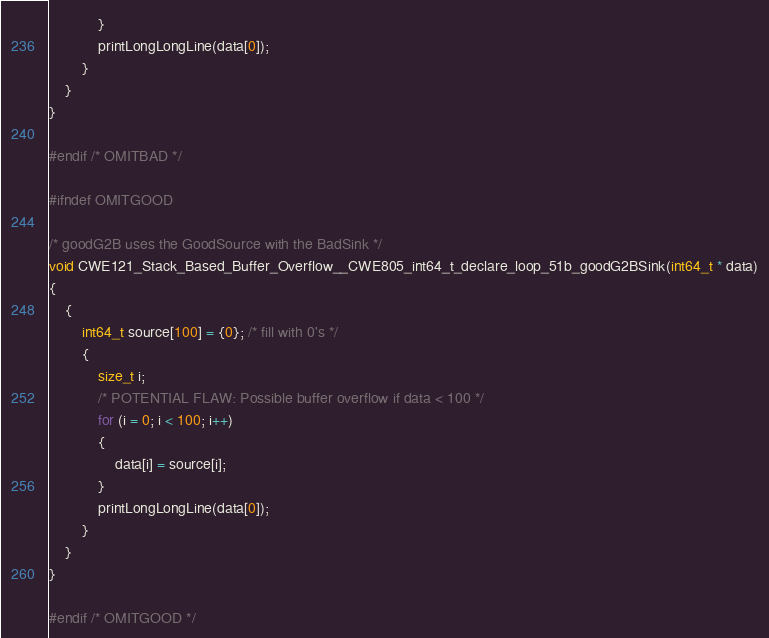Convert code to text. <code><loc_0><loc_0><loc_500><loc_500><_C_>            }
            printLongLongLine(data[0]);
        }
    }
}

#endif /* OMITBAD */

#ifndef OMITGOOD

/* goodG2B uses the GoodSource with the BadSink */
void CWE121_Stack_Based_Buffer_Overflow__CWE805_int64_t_declare_loop_51b_goodG2BSink(int64_t * data)
{
    {
        int64_t source[100] = {0}; /* fill with 0's */
        {
            size_t i;
            /* POTENTIAL FLAW: Possible buffer overflow if data < 100 */
            for (i = 0; i < 100; i++)
            {
                data[i] = source[i];
            }
            printLongLongLine(data[0]);
        }
    }
}

#endif /* OMITGOOD */
</code> 